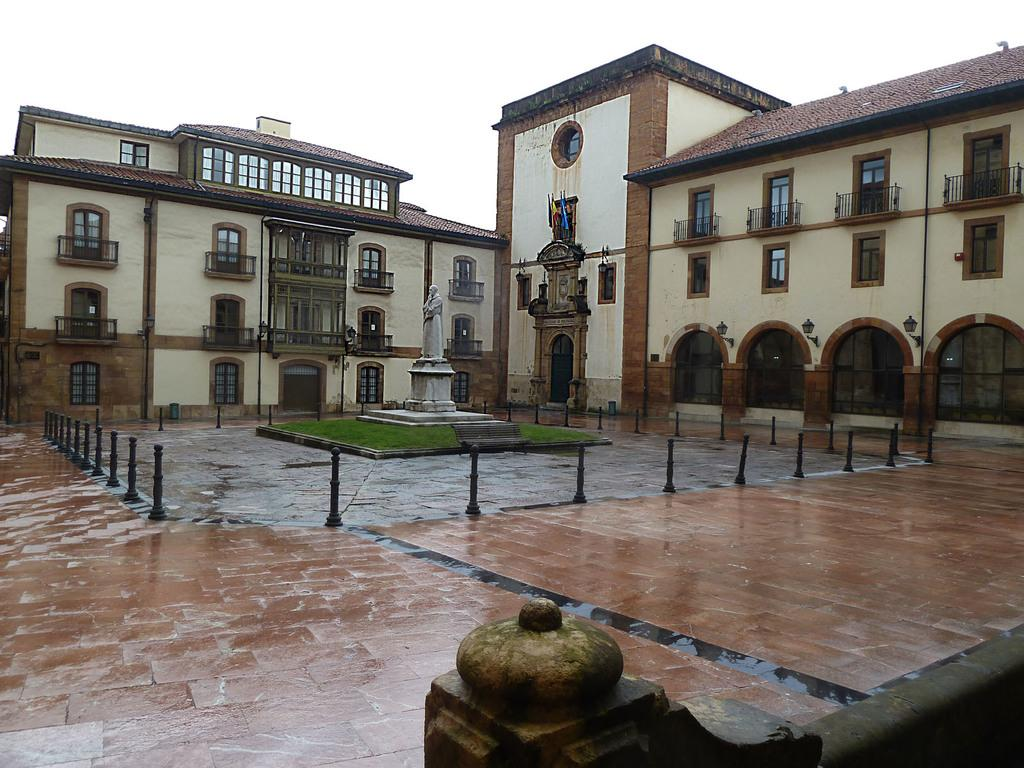What type of structures can be seen in the image? There are buildings in the image. What is located on the pedestal in the image? There is a statue on the pedestal in the image. What is the statue standing on? The statue is standing on a pedestal in the image. What can be seen beneath the statue? The ground is visible in the image. What might be used to control traffic or prevent vehicles from entering a certain area in the image? Barrier poles are present in the image. What is visible above the buildings and statue in the image? The sky is visible in the image. What type of news can be heard coming from the statue in the image? There is no indication in the image that the statue is producing or broadcasting any news. 